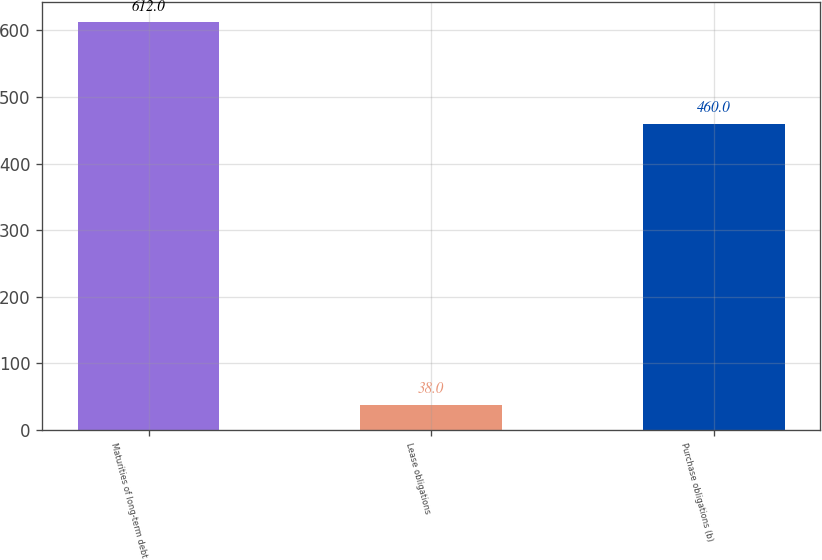Convert chart to OTSL. <chart><loc_0><loc_0><loc_500><loc_500><bar_chart><fcel>Maturities of long-term debt<fcel>Lease obligations<fcel>Purchase obligations (b)<nl><fcel>612<fcel>38<fcel>460<nl></chart> 